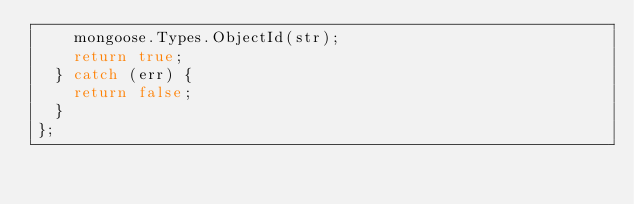<code> <loc_0><loc_0><loc_500><loc_500><_JavaScript_>    mongoose.Types.ObjectId(str);
    return true;
  } catch (err) {
    return false;
  }
};
</code> 